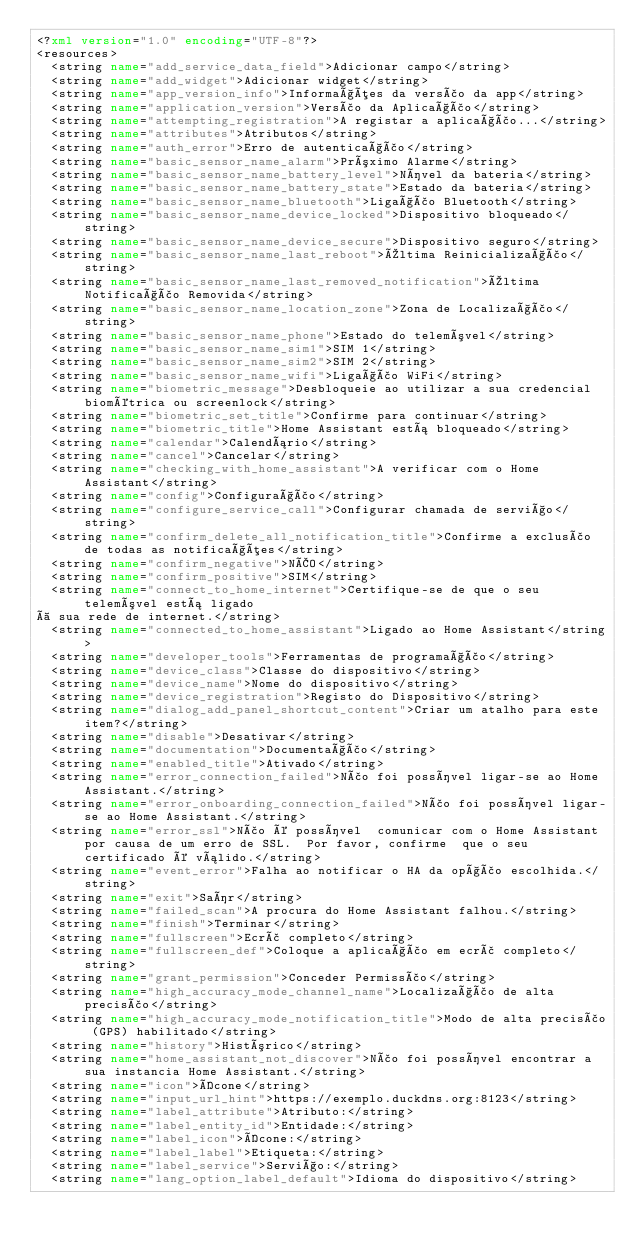Convert code to text. <code><loc_0><loc_0><loc_500><loc_500><_XML_><?xml version="1.0" encoding="UTF-8"?>
<resources>
  <string name="add_service_data_field">Adicionar campo</string>
  <string name="add_widget">Adicionar widget</string>
  <string name="app_version_info">Informações da versão da app</string>
  <string name="application_version">Versão da Aplicação</string>
  <string name="attempting_registration">A registar a aplicação...</string>
  <string name="attributes">Atributos</string>
  <string name="auth_error">Erro de autenticação</string>
  <string name="basic_sensor_name_alarm">Próximo Alarme</string>
  <string name="basic_sensor_name_battery_level">Nível da bateria</string>
  <string name="basic_sensor_name_battery_state">Estado da bateria</string>
  <string name="basic_sensor_name_bluetooth">Ligação Bluetooth</string>
  <string name="basic_sensor_name_device_locked">Dispositivo bloqueado</string>
  <string name="basic_sensor_name_device_secure">Dispositivo seguro</string>
  <string name="basic_sensor_name_last_reboot">Última Reinicialização</string>
  <string name="basic_sensor_name_last_removed_notification">Última Notificação Removida</string>
  <string name="basic_sensor_name_location_zone">Zona de Localização</string>
  <string name="basic_sensor_name_phone">Estado do telemóvel</string>
  <string name="basic_sensor_name_sim1">SIM 1</string>
  <string name="basic_sensor_name_sim2">SIM 2</string>
  <string name="basic_sensor_name_wifi">Ligação WiFi</string>
  <string name="biometric_message">Desbloqueie ao utilizar a sua credencial biométrica ou screenlock</string>
  <string name="biometric_set_title">Confirme para continuar</string>
  <string name="biometric_title">Home Assistant está bloqueado</string>
  <string name="calendar">Calendário</string>
  <string name="cancel">Cancelar</string>
  <string name="checking_with_home_assistant">A verificar com o Home Assistant</string>
  <string name="config">Configuração</string>
  <string name="configure_service_call">Configurar chamada de serviço</string>
  <string name="confirm_delete_all_notification_title">Confirme a exclusão de todas as notificações</string>
  <string name="confirm_negative">NÃO</string>
  <string name="confirm_positive">SIM</string>
  <string name="connect_to_home_internet">Certifique-se de que o seu telemóvel está ligado
à sua rede de internet.</string>
  <string name="connected_to_home_assistant">Ligado ao Home Assistant</string>
  <string name="developer_tools">Ferramentas de programação</string>
  <string name="device_class">Classe do dispositivo</string>
  <string name="device_name">Nome do dispositivo</string>
  <string name="device_registration">Registo do Dispositivo</string>
  <string name="dialog_add_panel_shortcut_content">Criar um atalho para este item?</string>
  <string name="disable">Desativar</string>
  <string name="documentation">Documentação</string>
  <string name="enabled_title">Ativado</string>
  <string name="error_connection_failed">Não foi possível ligar-se ao Home Assistant.</string>
  <string name="error_onboarding_connection_failed">Não foi possível ligar-se ao Home Assistant.</string>
  <string name="error_ssl">Não é possível  comunicar com o Home Assistant por causa de um erro de SSL.  Por favor, confirme  que o seu certificado é válido.</string>
  <string name="event_error">Falha ao notificar o HA da opção escolhida.</string>
  <string name="exit">Saír</string>
  <string name="failed_scan">A procura do Home Assistant falhou.</string>
  <string name="finish">Terminar</string>
  <string name="fullscreen">Ecrã completo</string>
  <string name="fullscreen_def">Coloque a aplicação em ecrã completo</string>
  <string name="grant_permission">Conceder Permissão</string>
  <string name="high_accuracy_mode_channel_name">Localização de alta precisão</string>
  <string name="high_accuracy_mode_notification_title">Modo de alta precisão (GPS) habilitado</string>
  <string name="history">Histórico</string>
  <string name="home_assistant_not_discover">Não foi possível encontrar a sua instancia Home Assistant.</string>
  <string name="icon">Ícone</string>
  <string name="input_url_hint">https://exemplo.duckdns.org:8123</string>
  <string name="label_attribute">Atributo:</string>
  <string name="label_entity_id">Entidade:</string>
  <string name="label_icon">Ícone:</string>
  <string name="label_label">Etiqueta:</string>
  <string name="label_service">Serviço:</string>
  <string name="lang_option_label_default">Idioma do dispositivo</string></code> 